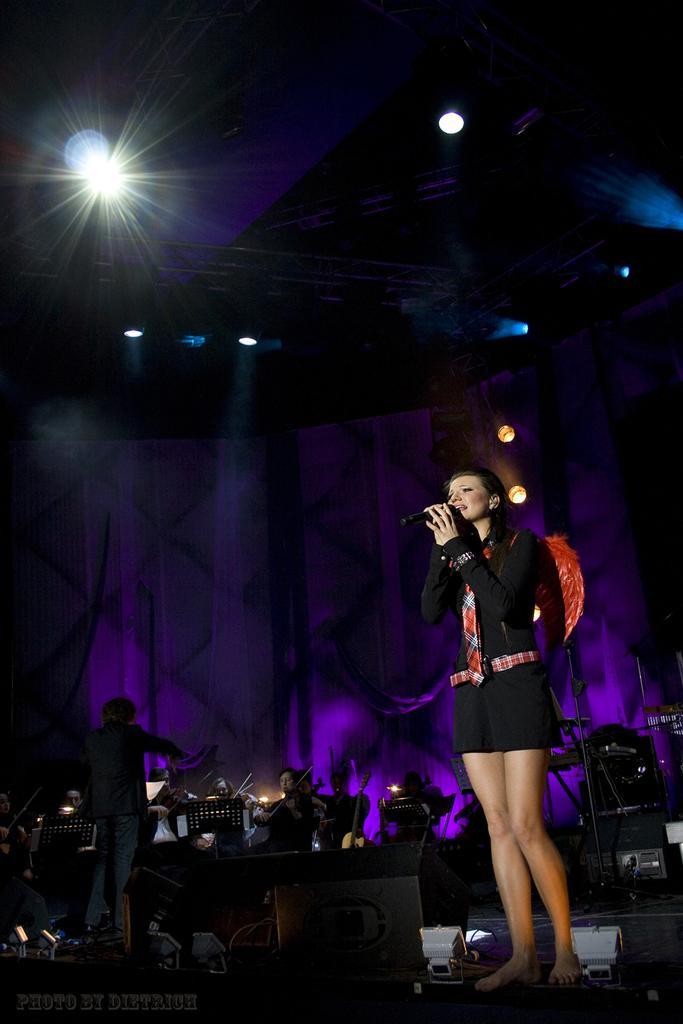Please provide a concise description of this image. At the right corner of the image there is a lady with black dress is standing and holding the mic in her hands. Behind her in the background there are many people sitting and playing musical instruments. Also there is a man with black dress is stunning. On the stage there are speakers. In the background there is a violet color lighting. At the top of the image there are rods also there are lights. 